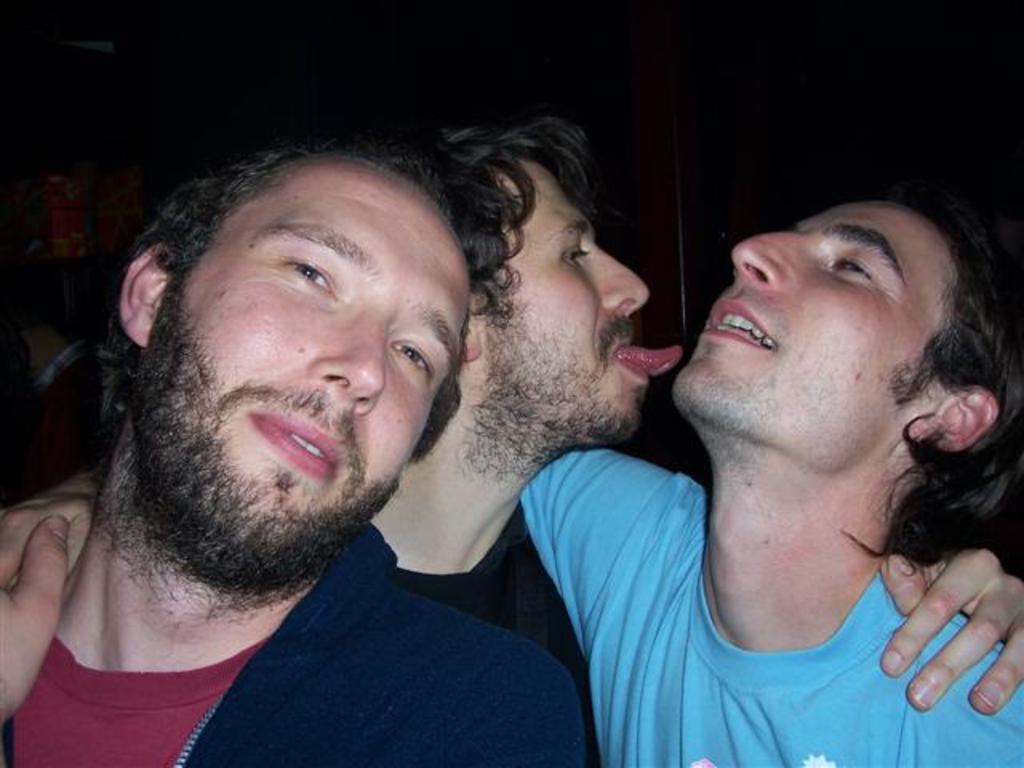In one or two sentences, can you explain what this image depicts? In the middle of the image there are three men. In this image the background is dark. 